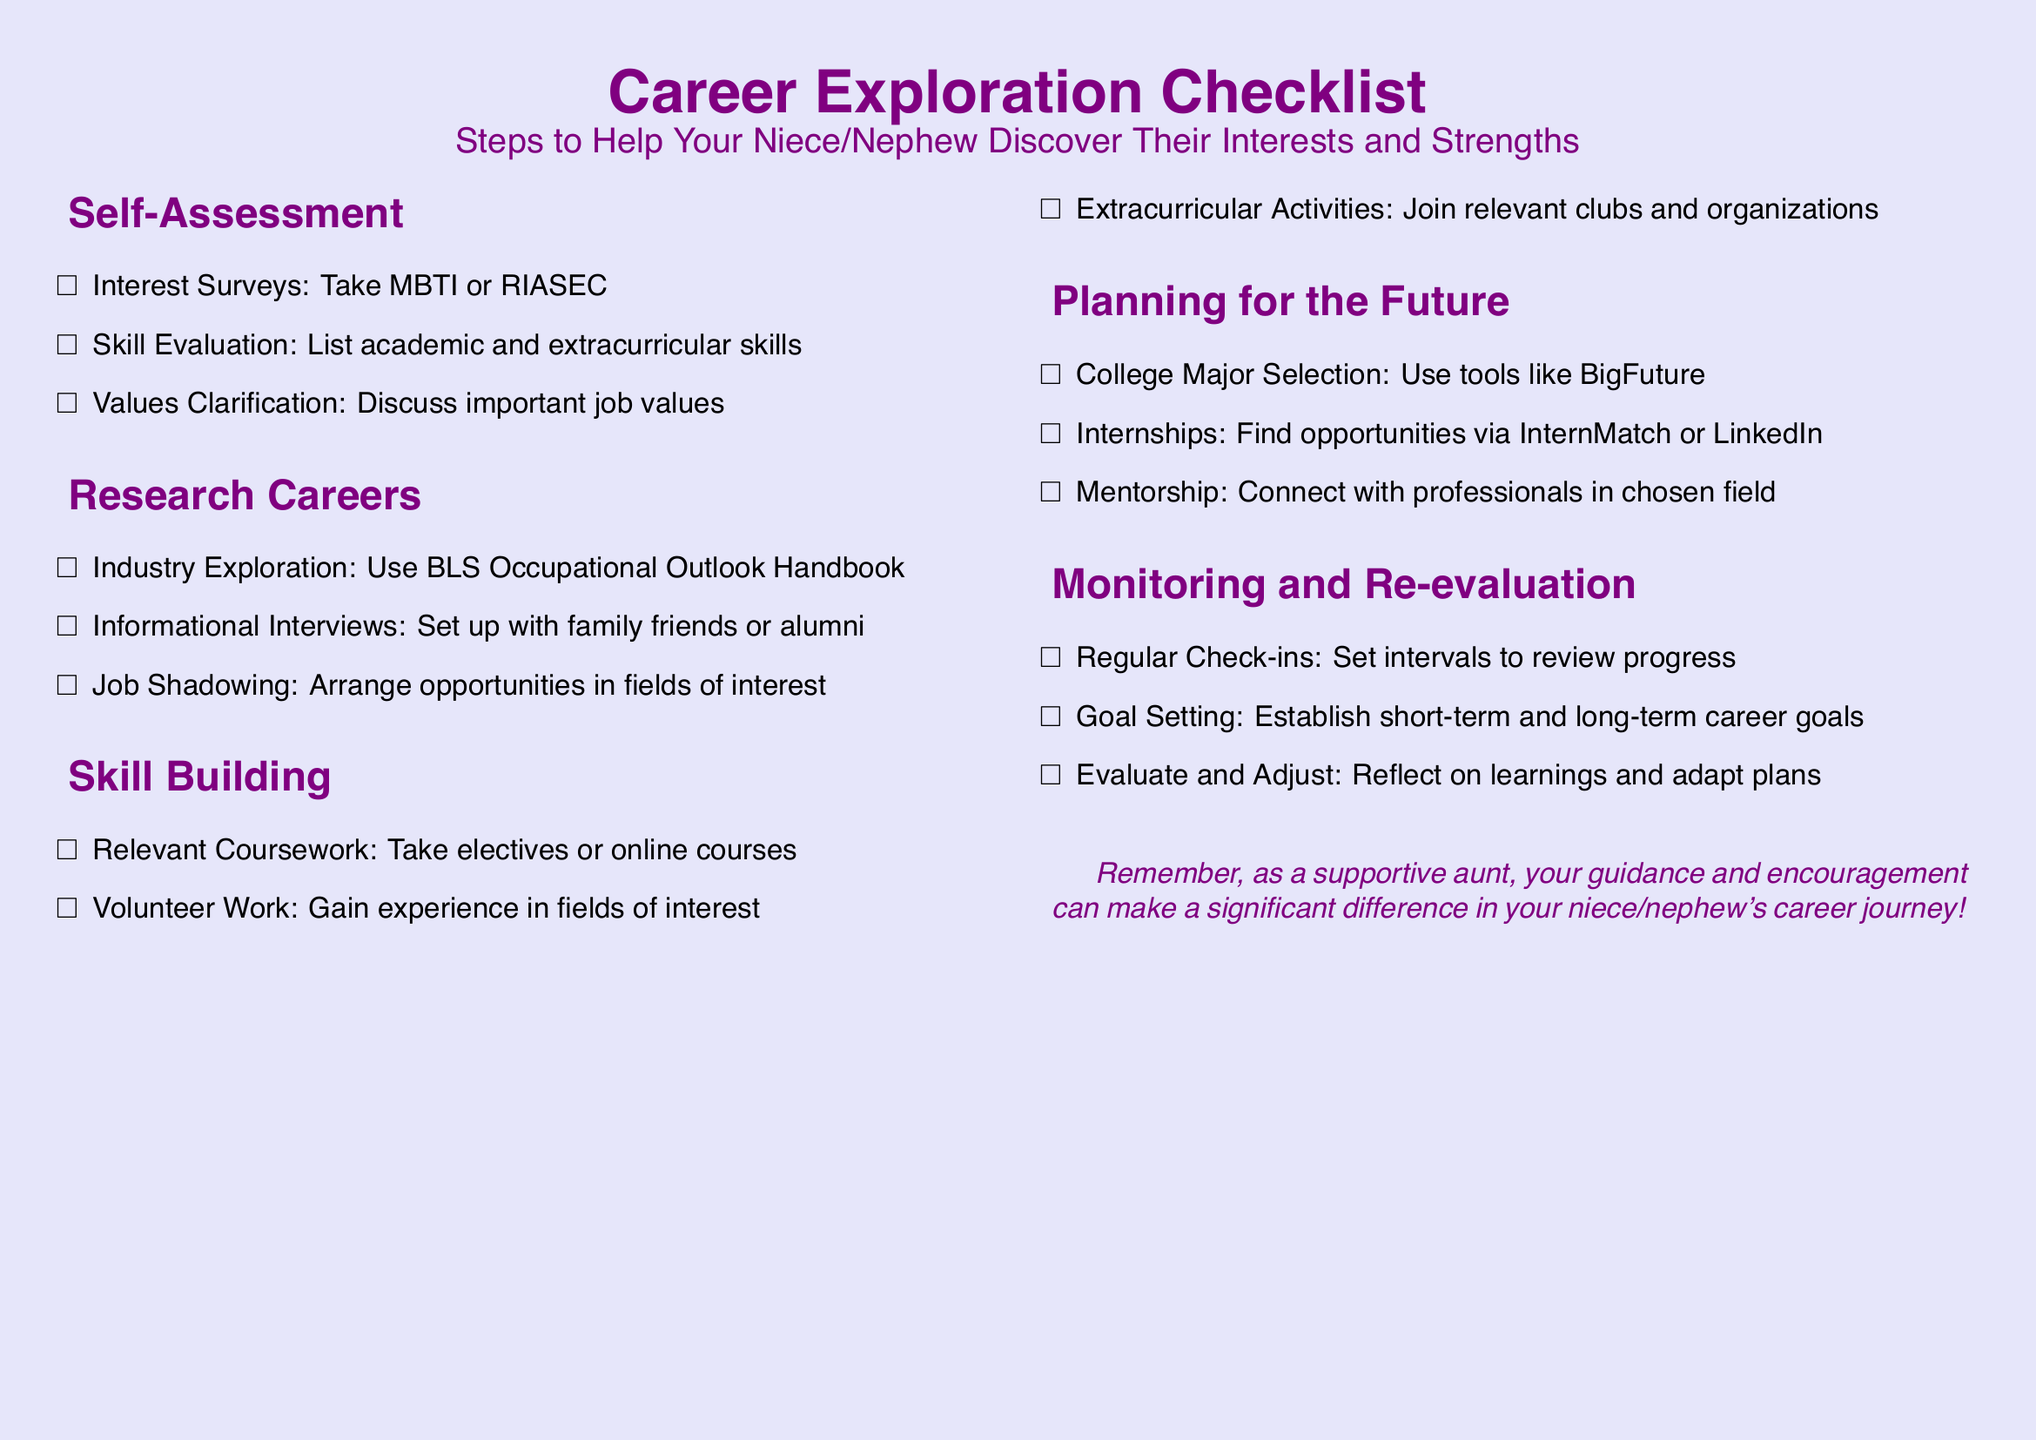What is a recommended tool for college major selection? The document suggests using tools like BigFuture for college major selection.
Answer: BigFuture How many sections are in the checklist? The checklist has five sections: Self-Assessment, Research Careers, Skill Building, Planning for the Future, and Monitoring and Re-evaluation.
Answer: Five What type of courses should be taken to build relevant skills? The checklist mentions taking electives or online courses to build relevant skills.
Answer: Electives or online courses What is one way to explore industries? The document recommends using the BLS Occupational Outlook Handbook to explore industries.
Answer: BLS Occupational Outlook Handbook How often should regular check-ins be set? The document does not specify a number but indicates that intervals should be set for regular check-ins to review progress.
Answer: Intervals What can your niece/nephew gain from volunteering? Gaining experience in fields of interest is the benefit noted in the checklist regarding volunteer work.
Answer: Experience What type of professionals should be connected with for mentorship? The checklist recommends connecting with professionals in the chosen field for mentorship.
Answer: Professionals in the chosen field Which type of interviews are suggested in the Research Careers section? Informational interviews are suggested to set up with family friends or alumni.
Answer: Informational interviews What is a suggested activity to join for skill building? The document suggests joining relevant clubs and organizations as an activity to build skills.
Answer: Relevant clubs and organizations 